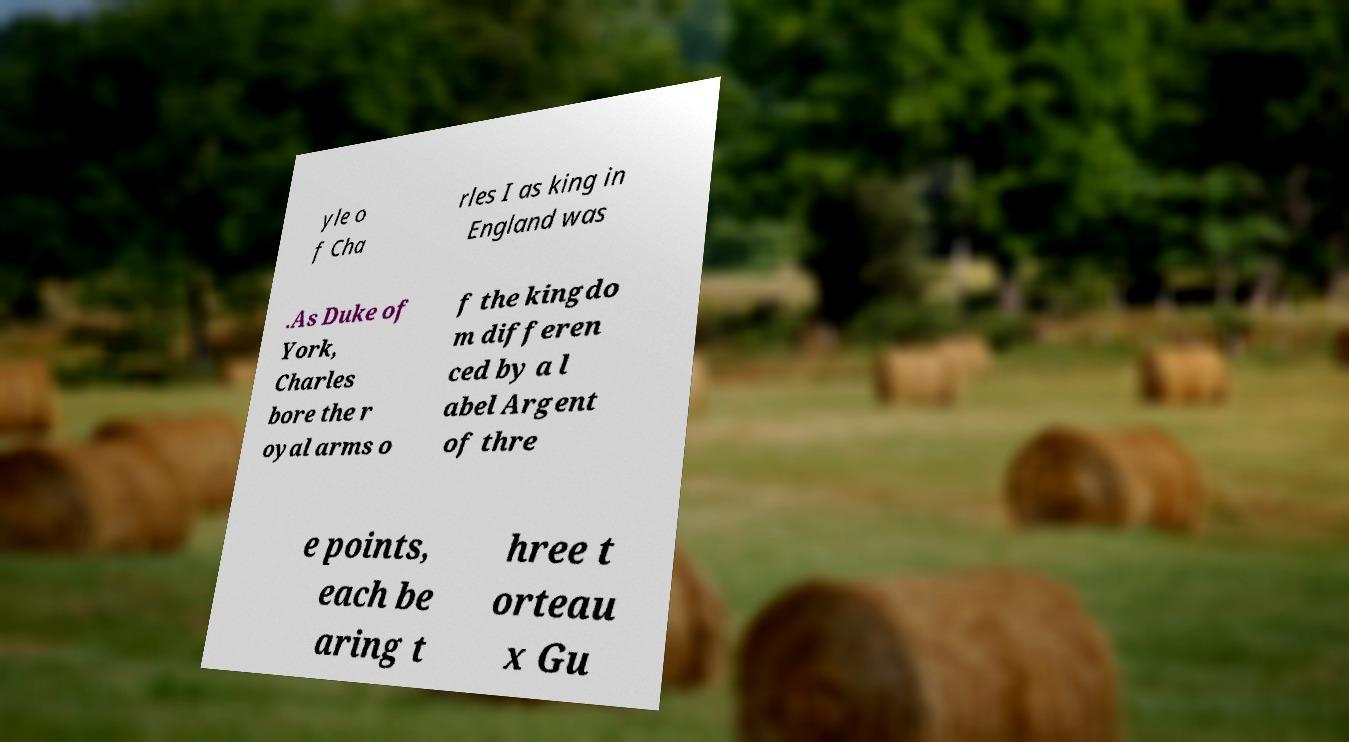Can you read and provide the text displayed in the image?This photo seems to have some interesting text. Can you extract and type it out for me? yle o f Cha rles I as king in England was .As Duke of York, Charles bore the r oyal arms o f the kingdo m differen ced by a l abel Argent of thre e points, each be aring t hree t orteau x Gu 